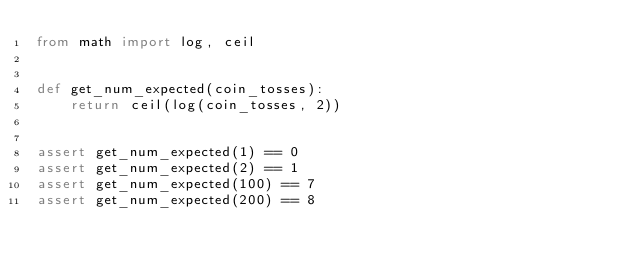<code> <loc_0><loc_0><loc_500><loc_500><_Python_>from math import log, ceil


def get_num_expected(coin_tosses):
    return ceil(log(coin_tosses, 2))


assert get_num_expected(1) == 0
assert get_num_expected(2) == 1
assert get_num_expected(100) == 7
assert get_num_expected(200) == 8
</code> 